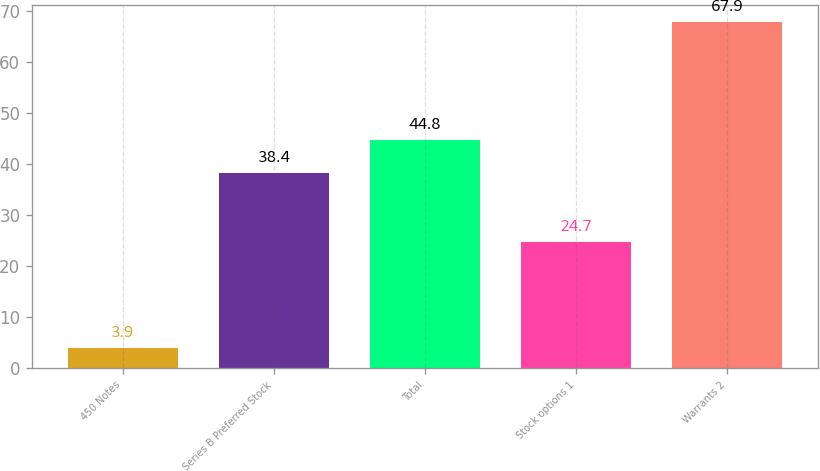<chart> <loc_0><loc_0><loc_500><loc_500><bar_chart><fcel>450 Notes<fcel>Series B Preferred Stock<fcel>Total<fcel>Stock options 1<fcel>Warrants 2<nl><fcel>3.9<fcel>38.4<fcel>44.8<fcel>24.7<fcel>67.9<nl></chart> 